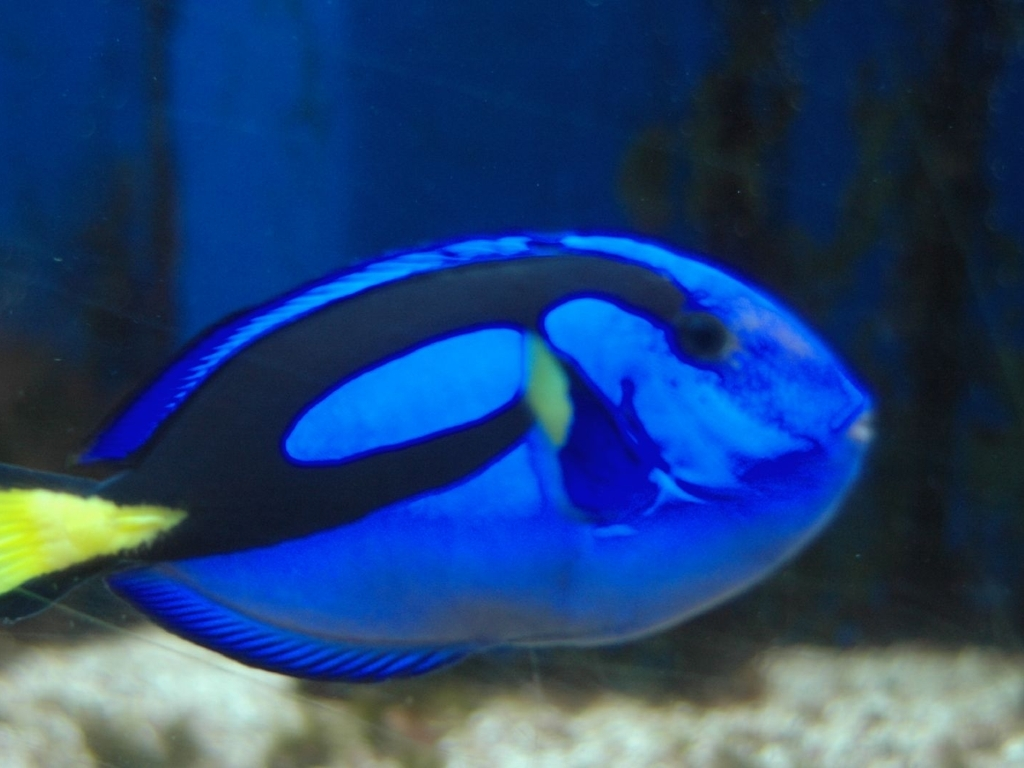How is the background in the image?
A. Heavily blurred
B. Sharp
C. In focus
Answer with the option's letter from the given choices directly.
 A. 